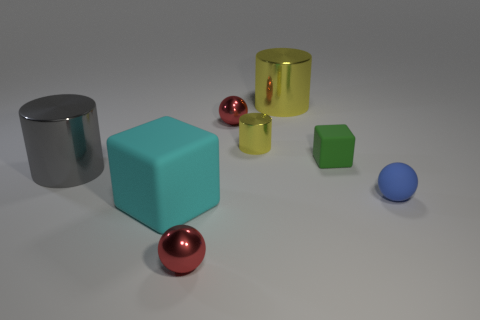Subtract all big shiny cylinders. How many cylinders are left? 1 Add 1 small red objects. How many objects exist? 9 Subtract all blue spheres. How many spheres are left? 2 Subtract all spheres. How many objects are left? 5 Subtract all green cubes. Subtract all brown spheres. How many cubes are left? 1 Subtract all gray balls. How many gray cylinders are left? 1 Subtract all large gray objects. Subtract all tiny matte spheres. How many objects are left? 6 Add 1 tiny blue matte balls. How many tiny blue matte balls are left? 2 Add 3 tiny yellow objects. How many tiny yellow objects exist? 4 Subtract 1 gray cylinders. How many objects are left? 7 